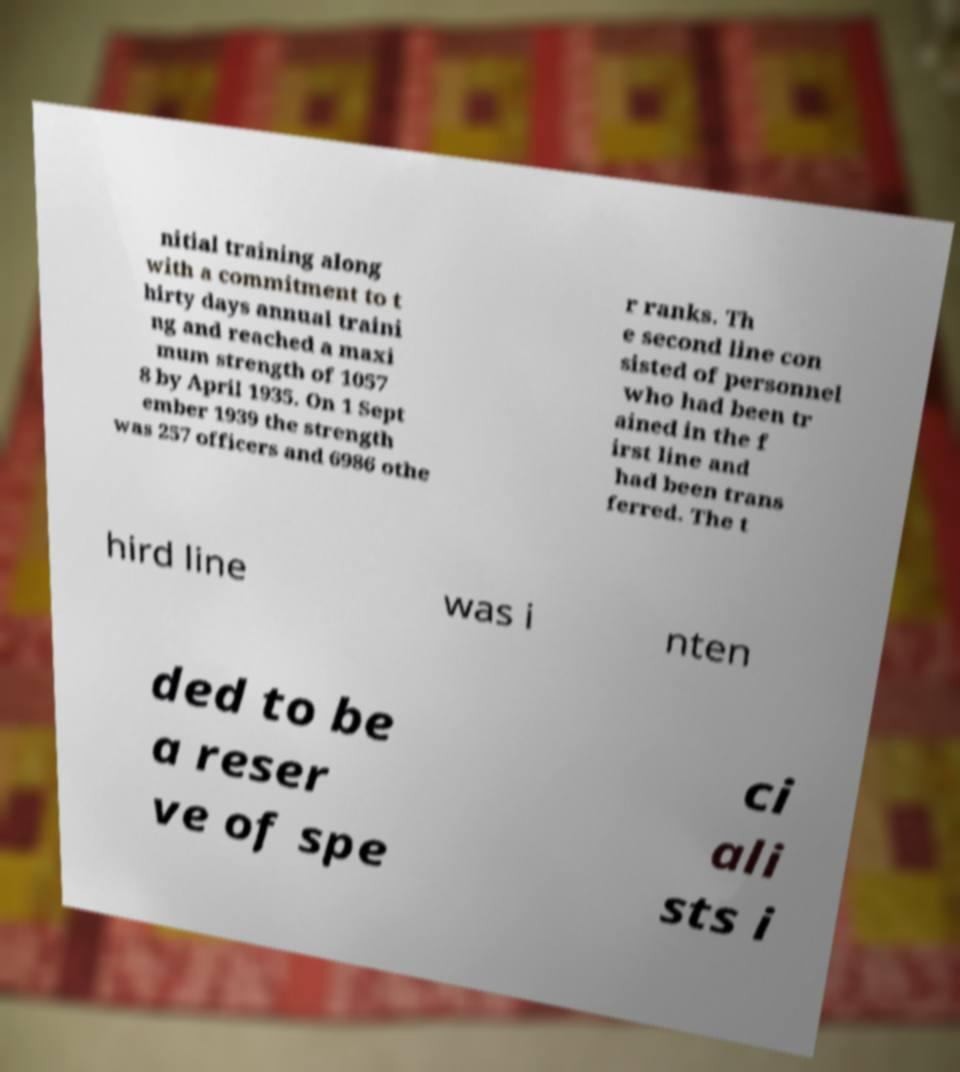For documentation purposes, I need the text within this image transcribed. Could you provide that? nitial training along with a commitment to t hirty days annual traini ng and reached a maxi mum strength of 1057 8 by April 1935. On 1 Sept ember 1939 the strength was 257 officers and 6986 othe r ranks. Th e second line con sisted of personnel who had been tr ained in the f irst line and had been trans ferred. The t hird line was i nten ded to be a reser ve of spe ci ali sts i 